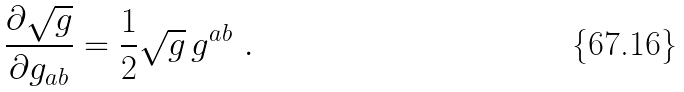<formula> <loc_0><loc_0><loc_500><loc_500>\frac { \partial \sqrt { g } } { \partial g _ { a b } } = \frac { 1 } { 2 } \sqrt { g } \, g ^ { a b } \ .</formula> 